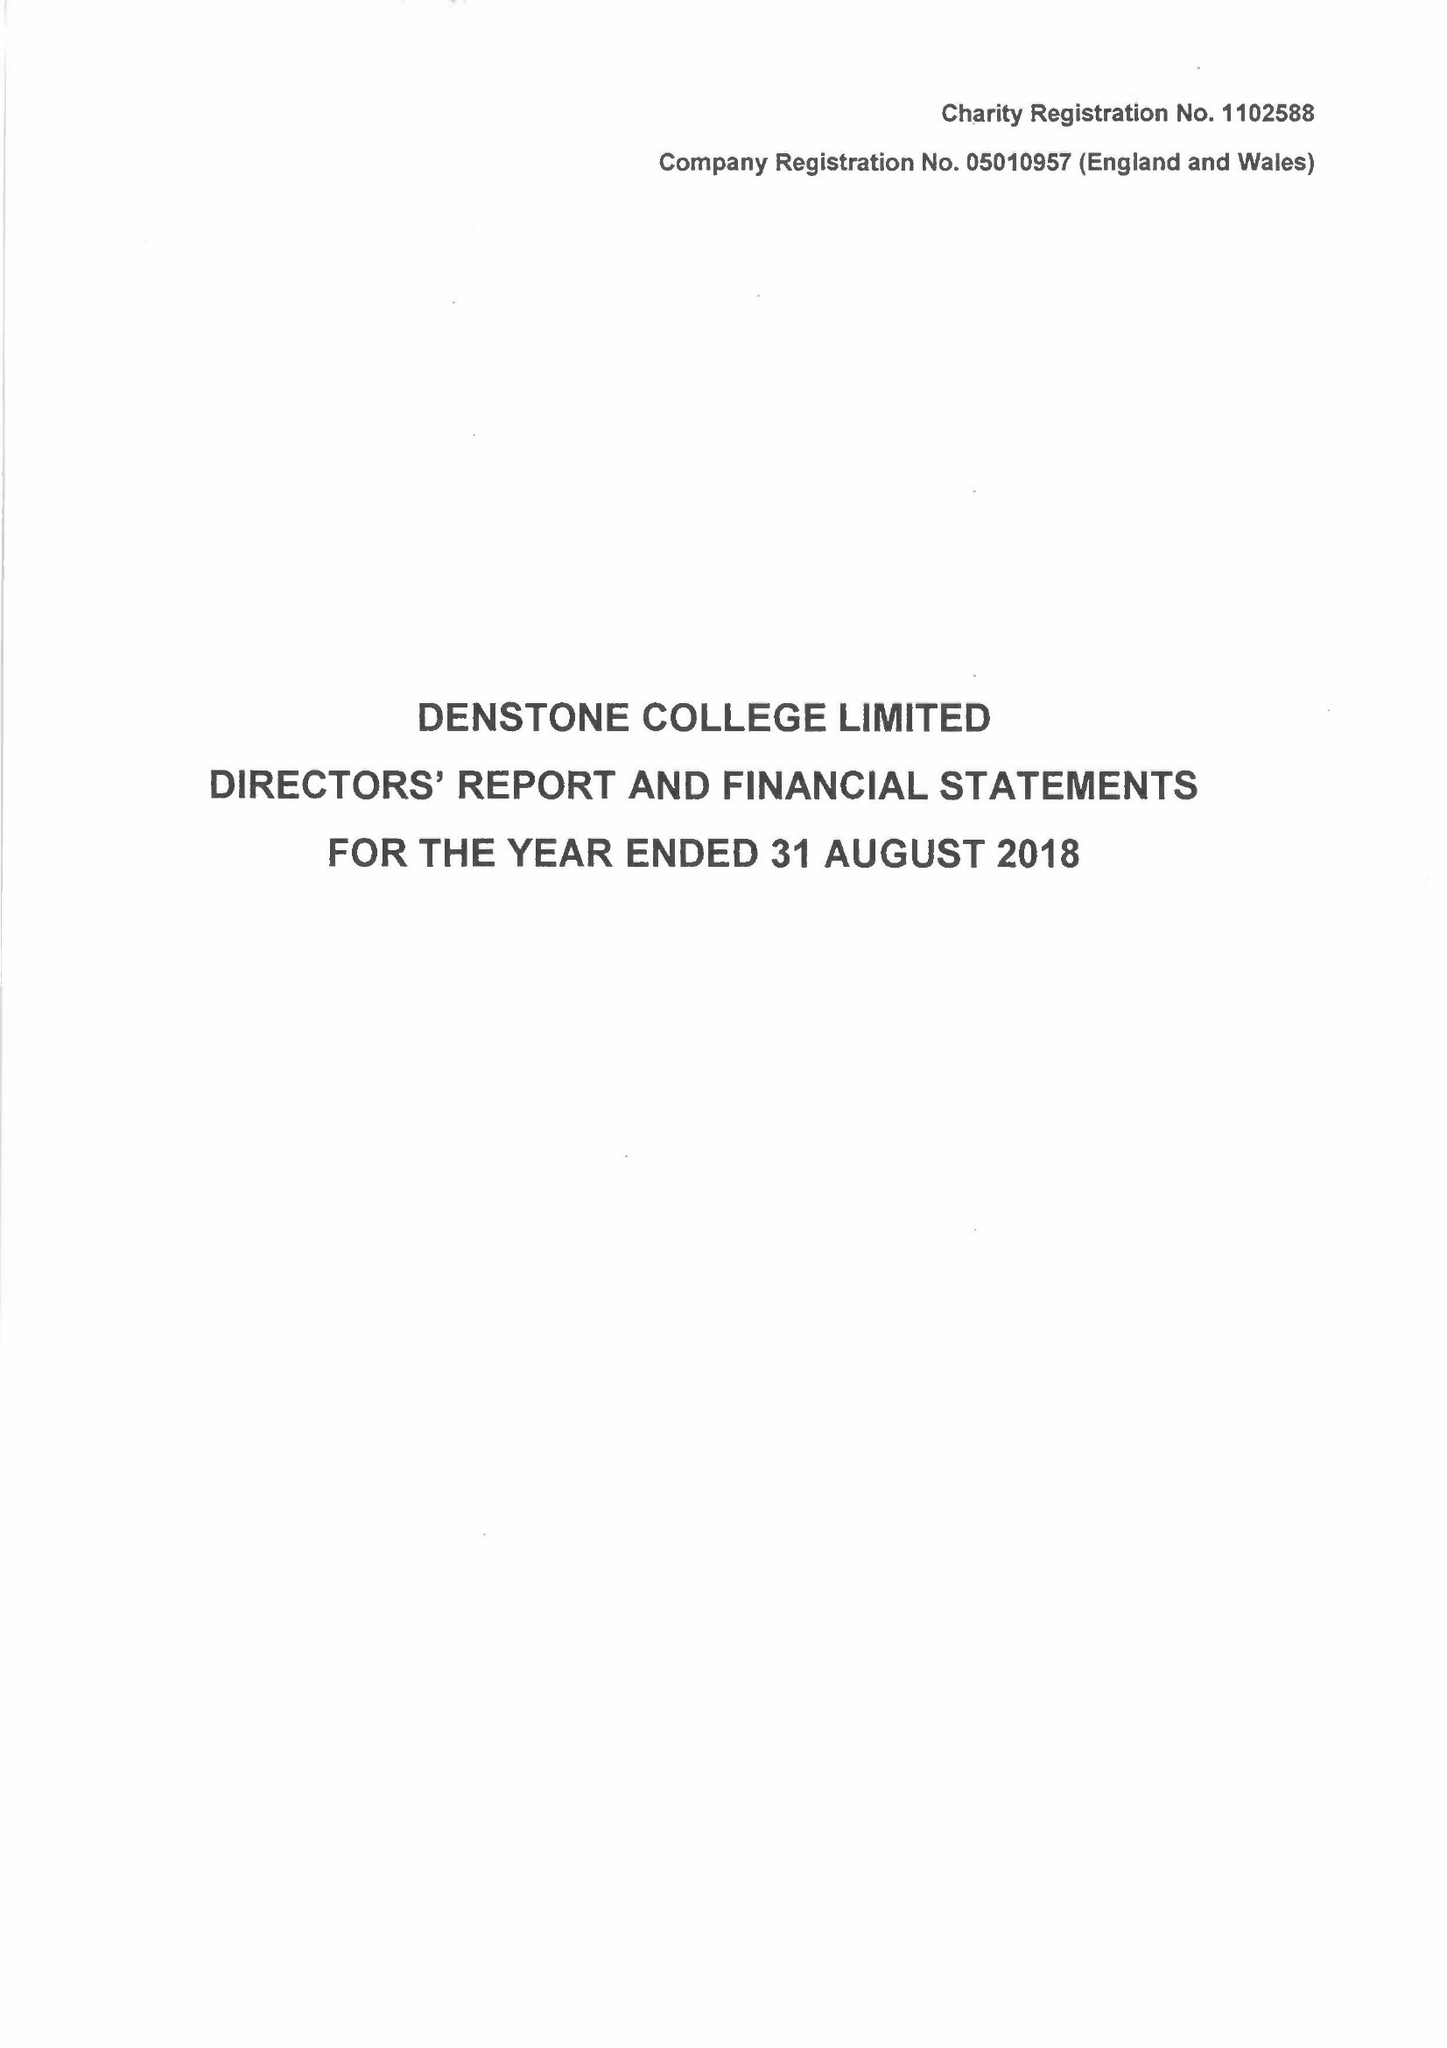What is the value for the charity_name?
Answer the question using a single word or phrase. Denstone College Ltd. 